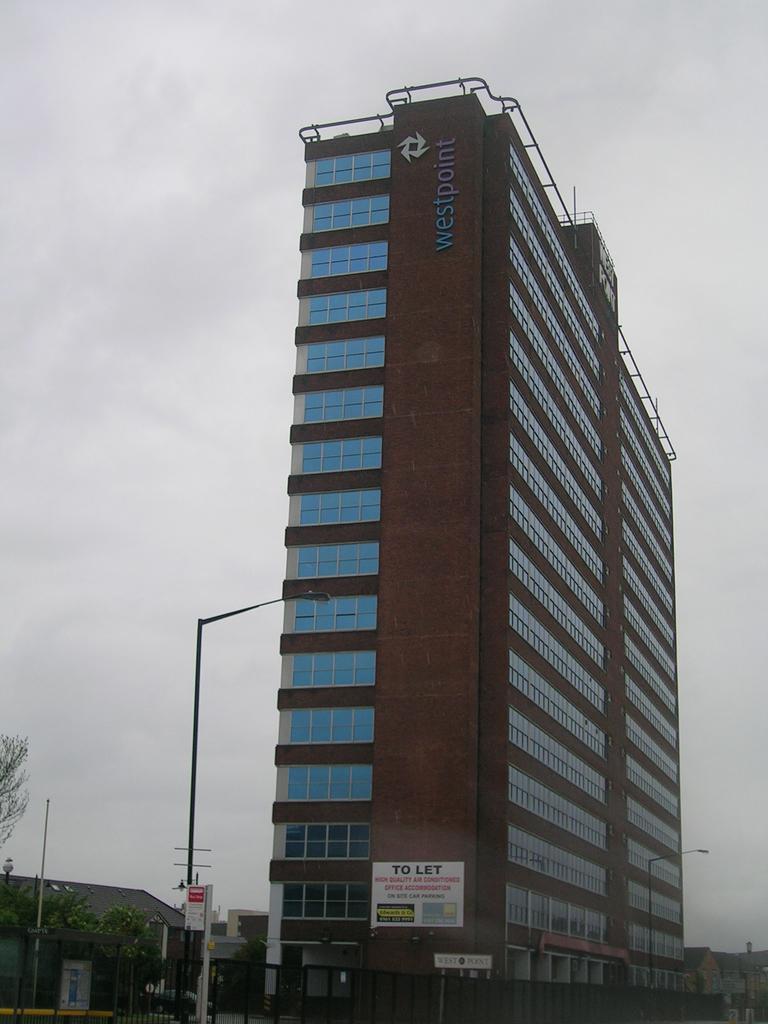How would you summarize this image in a sentence or two? In this image there is a tall building in the middle. At the top there is the sky. At the bottom there are electric poles. There is a to-let board attached to the wall. On the left side there are trees. 